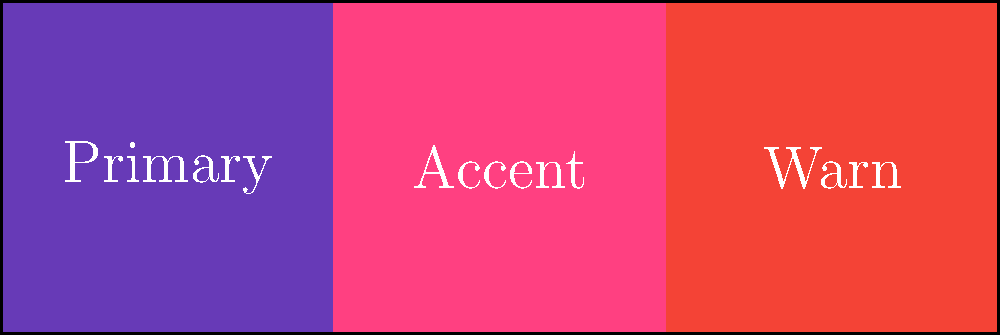In Angular Material, which SCSS mixin is used to create a custom theme with the color palette shown in the image above? To create a custom theme in Angular Material using the color palette shown in the image, follow these steps:

1. First, define your custom color palettes using the `$mat-palette` function:
   ```scss
   $primary: mat-palette($mat-deep-purple);
   $accent: mat-palette($mat-pink, A200, A100, A400);
   $warn: mat-palette($mat-red);
   ```

2. Create a theme object using the `mat-light-theme` function (or `mat-dark-theme` for a dark theme):
   ```scss
   $theme: mat-light-theme($primary, $accent, $warn);
   ```

3. Include the theme styles using the `@include angular-material-theme` mixin:
   ```scss
   @include angular-material-theme($theme);
   ```

The key mixin used to create and apply the custom theme is `angular-material-theme`. This mixin takes the theme object as an argument and generates all the necessary styles for Angular Material components based on the specified color palettes.
Answer: @include angular-material-theme($theme); 